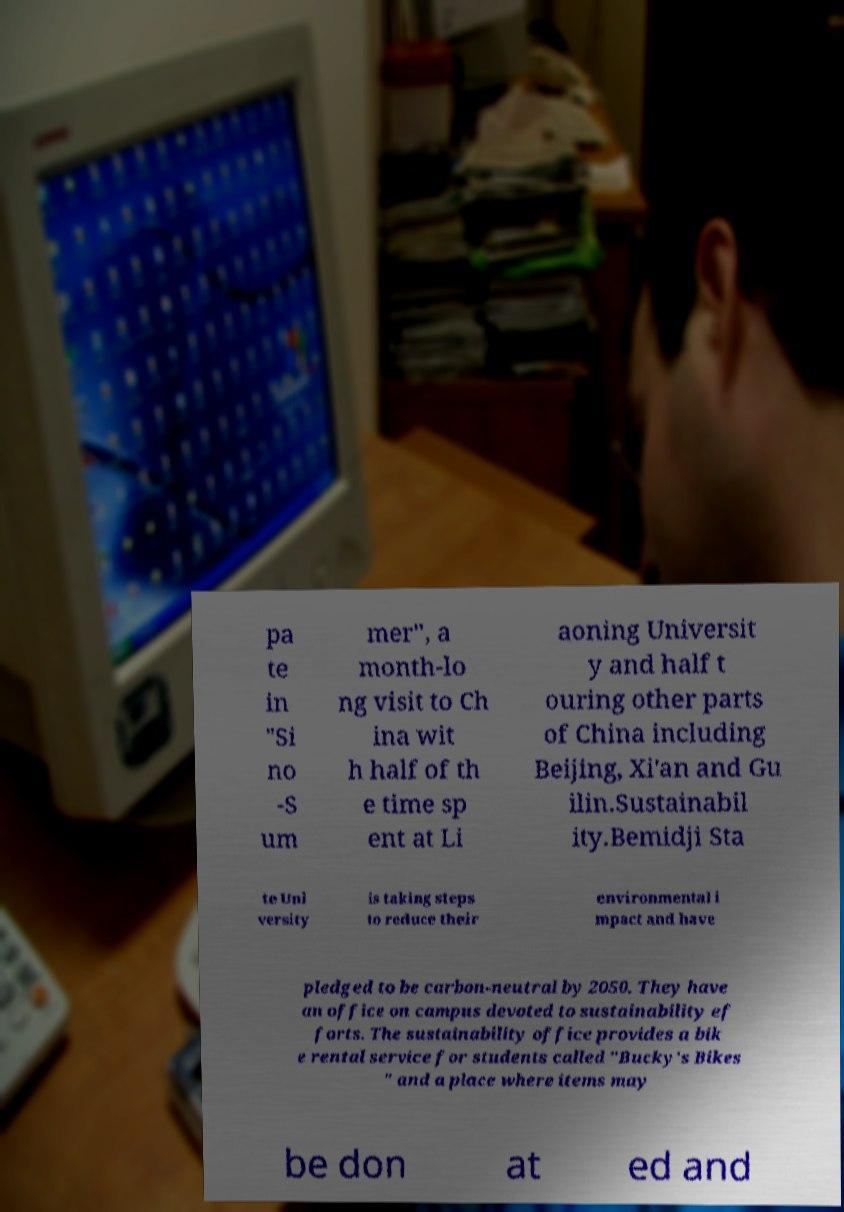Please identify and transcribe the text found in this image. pa te in "Si no -S um mer", a month-lo ng visit to Ch ina wit h half of th e time sp ent at Li aoning Universit y and half t ouring other parts of China including Beijing, Xi'an and Gu ilin.Sustainabil ity.Bemidji Sta te Uni versity is taking steps to reduce their environmental i mpact and have pledged to be carbon-neutral by 2050. They have an office on campus devoted to sustainability ef forts. The sustainability office provides a bik e rental service for students called "Bucky's Bikes " and a place where items may be don at ed and 